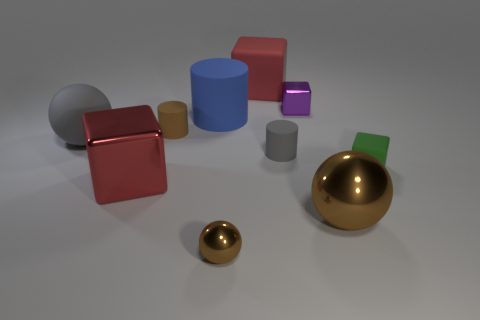Subtract 1 blocks. How many blocks are left? 3 Subtract all cylinders. How many objects are left? 7 Add 1 brown metal objects. How many brown metal objects are left? 3 Add 4 blue cylinders. How many blue cylinders exist? 5 Subtract 0 yellow balls. How many objects are left? 10 Subtract all cyan shiny spheres. Subtract all brown things. How many objects are left? 7 